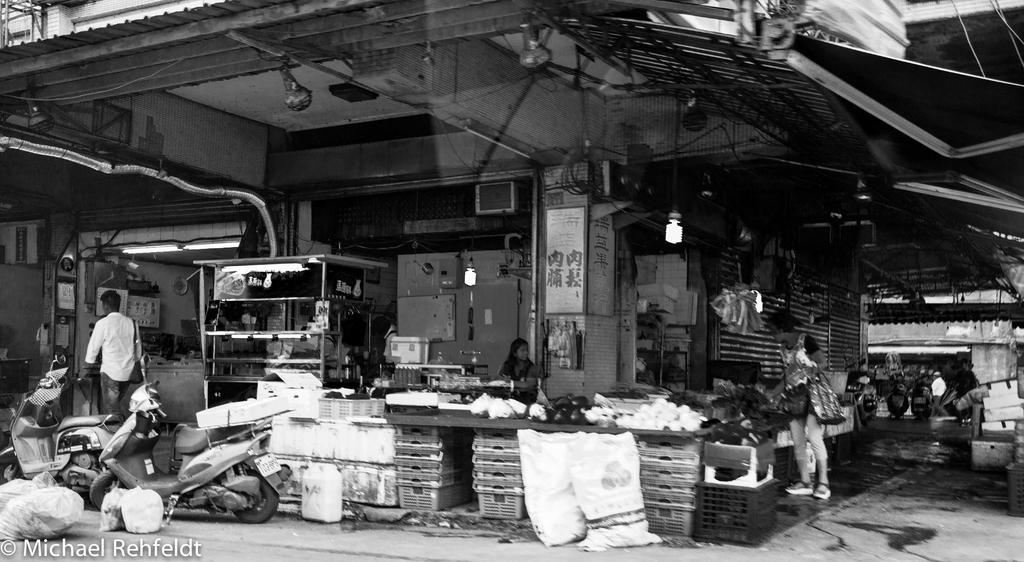Can you describe this image briefly? In this image we can see there is a grocery store. And there is a person standing and there are vegetables, table, baskets, light, shed, wall, board, pipeline and vehicles on the road. And there is another person walking. 